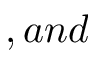<formula> <loc_0><loc_0><loc_500><loc_500>, a n d</formula> 